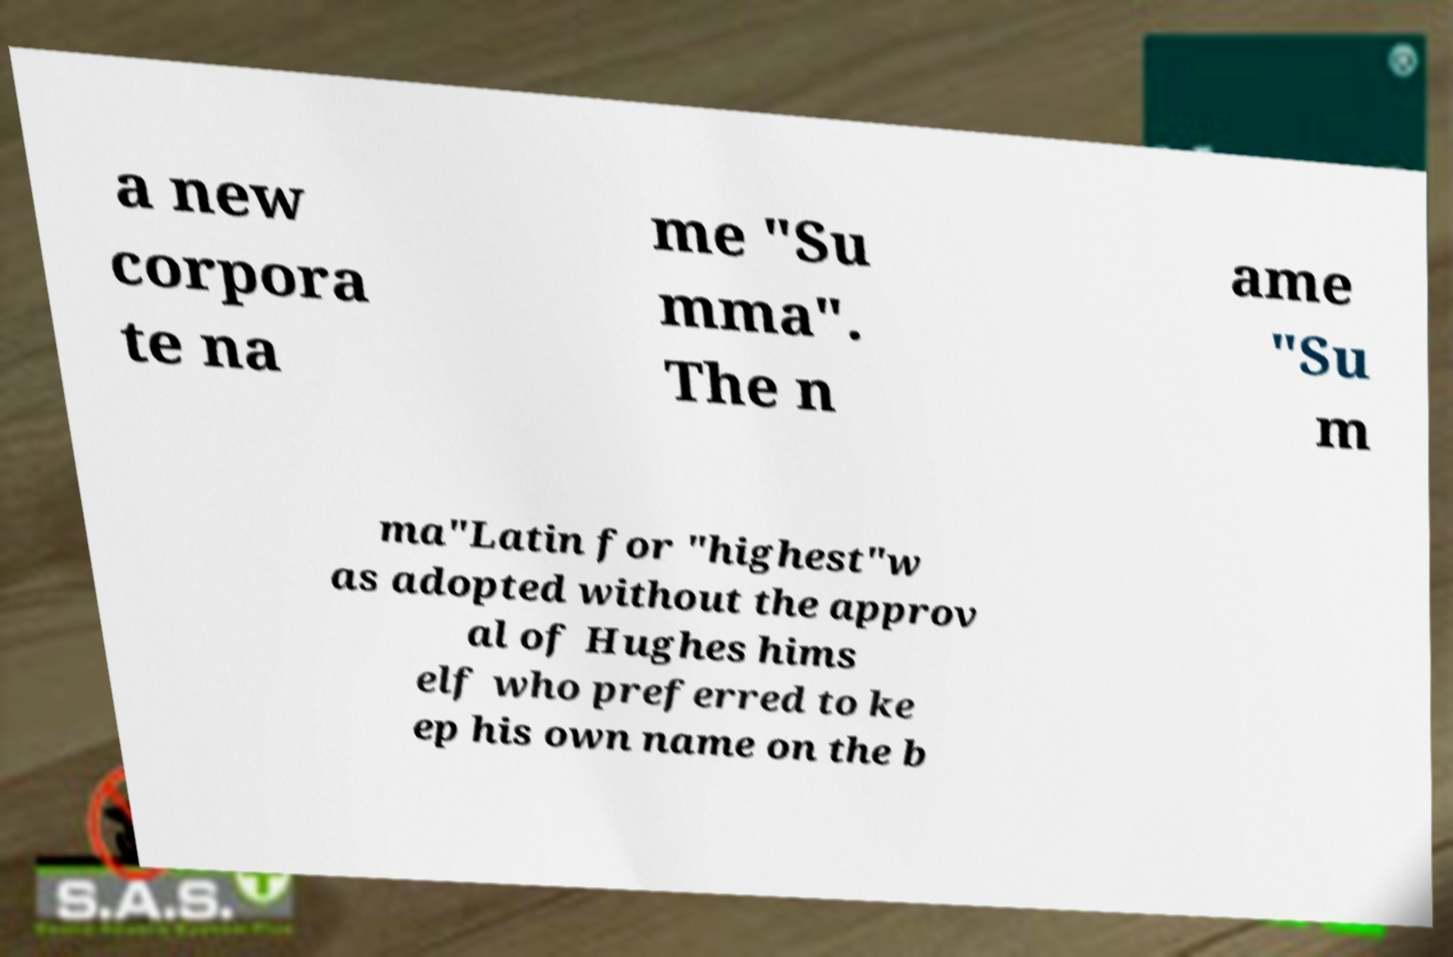For documentation purposes, I need the text within this image transcribed. Could you provide that? a new corpora te na me "Su mma". The n ame "Su m ma"Latin for "highest"w as adopted without the approv al of Hughes hims elf who preferred to ke ep his own name on the b 